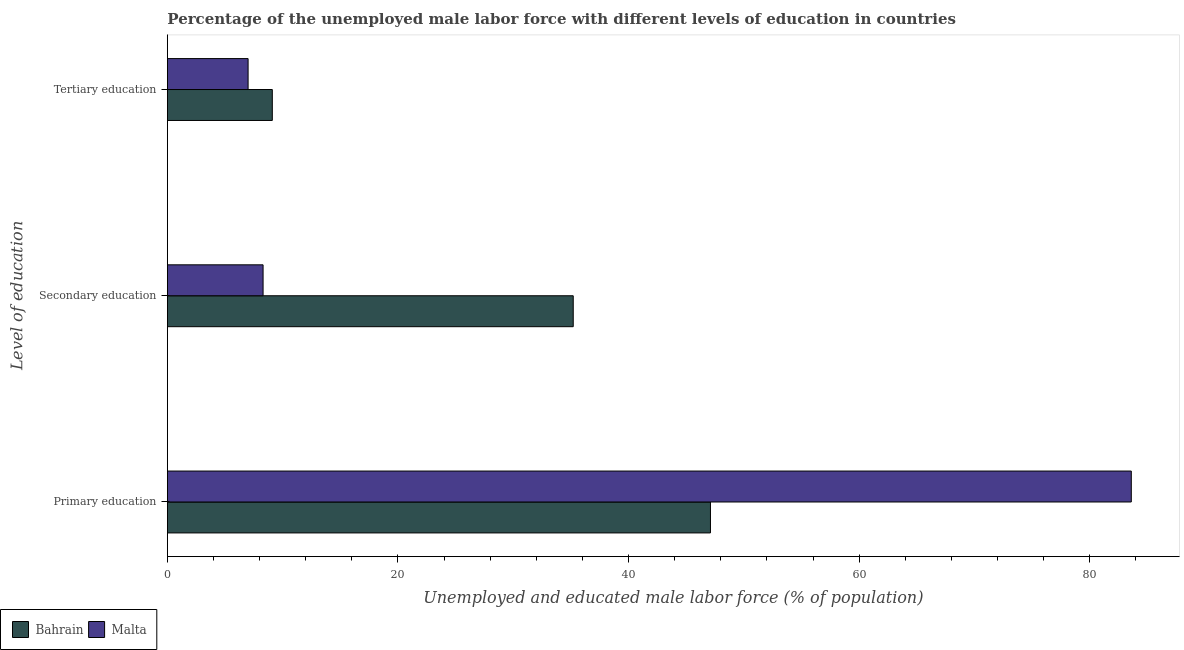How many groups of bars are there?
Give a very brief answer. 3. What is the label of the 2nd group of bars from the top?
Your answer should be very brief. Secondary education. What is the percentage of male labor force who received primary education in Bahrain?
Your answer should be very brief. 47.1. Across all countries, what is the maximum percentage of male labor force who received secondary education?
Provide a short and direct response. 35.2. In which country was the percentage of male labor force who received primary education maximum?
Your answer should be very brief. Malta. In which country was the percentage of male labor force who received secondary education minimum?
Offer a very short reply. Malta. What is the total percentage of male labor force who received tertiary education in the graph?
Provide a succinct answer. 16.1. What is the difference between the percentage of male labor force who received tertiary education in Malta and that in Bahrain?
Ensure brevity in your answer.  -2.1. What is the difference between the percentage of male labor force who received tertiary education in Bahrain and the percentage of male labor force who received secondary education in Malta?
Provide a succinct answer. 0.8. What is the average percentage of male labor force who received tertiary education per country?
Offer a very short reply. 8.05. What is the difference between the percentage of male labor force who received tertiary education and percentage of male labor force who received secondary education in Malta?
Keep it short and to the point. -1.3. What is the ratio of the percentage of male labor force who received secondary education in Malta to that in Bahrain?
Make the answer very short. 0.24. What is the difference between the highest and the second highest percentage of male labor force who received tertiary education?
Provide a short and direct response. 2.1. What is the difference between the highest and the lowest percentage of male labor force who received tertiary education?
Make the answer very short. 2.1. In how many countries, is the percentage of male labor force who received secondary education greater than the average percentage of male labor force who received secondary education taken over all countries?
Make the answer very short. 1. What does the 1st bar from the top in Secondary education represents?
Your response must be concise. Malta. What does the 1st bar from the bottom in Primary education represents?
Offer a very short reply. Bahrain. How many countries are there in the graph?
Your answer should be compact. 2. Are the values on the major ticks of X-axis written in scientific E-notation?
Provide a short and direct response. No. How many legend labels are there?
Offer a very short reply. 2. How are the legend labels stacked?
Your answer should be very brief. Horizontal. What is the title of the graph?
Keep it short and to the point. Percentage of the unemployed male labor force with different levels of education in countries. Does "Iran" appear as one of the legend labels in the graph?
Your answer should be compact. No. What is the label or title of the X-axis?
Provide a succinct answer. Unemployed and educated male labor force (% of population). What is the label or title of the Y-axis?
Provide a short and direct response. Level of education. What is the Unemployed and educated male labor force (% of population) in Bahrain in Primary education?
Offer a very short reply. 47.1. What is the Unemployed and educated male labor force (% of population) of Malta in Primary education?
Keep it short and to the point. 83.6. What is the Unemployed and educated male labor force (% of population) of Bahrain in Secondary education?
Your answer should be compact. 35.2. What is the Unemployed and educated male labor force (% of population) in Malta in Secondary education?
Give a very brief answer. 8.3. What is the Unemployed and educated male labor force (% of population) in Bahrain in Tertiary education?
Keep it short and to the point. 9.1. Across all Level of education, what is the maximum Unemployed and educated male labor force (% of population) in Bahrain?
Keep it short and to the point. 47.1. Across all Level of education, what is the maximum Unemployed and educated male labor force (% of population) of Malta?
Provide a succinct answer. 83.6. Across all Level of education, what is the minimum Unemployed and educated male labor force (% of population) in Bahrain?
Offer a terse response. 9.1. What is the total Unemployed and educated male labor force (% of population) in Bahrain in the graph?
Give a very brief answer. 91.4. What is the total Unemployed and educated male labor force (% of population) in Malta in the graph?
Keep it short and to the point. 98.9. What is the difference between the Unemployed and educated male labor force (% of population) in Bahrain in Primary education and that in Secondary education?
Offer a terse response. 11.9. What is the difference between the Unemployed and educated male labor force (% of population) of Malta in Primary education and that in Secondary education?
Provide a succinct answer. 75.3. What is the difference between the Unemployed and educated male labor force (% of population) in Malta in Primary education and that in Tertiary education?
Offer a terse response. 76.6. What is the difference between the Unemployed and educated male labor force (% of population) of Bahrain in Secondary education and that in Tertiary education?
Your answer should be very brief. 26.1. What is the difference between the Unemployed and educated male labor force (% of population) of Bahrain in Primary education and the Unemployed and educated male labor force (% of population) of Malta in Secondary education?
Your response must be concise. 38.8. What is the difference between the Unemployed and educated male labor force (% of population) in Bahrain in Primary education and the Unemployed and educated male labor force (% of population) in Malta in Tertiary education?
Offer a terse response. 40.1. What is the difference between the Unemployed and educated male labor force (% of population) of Bahrain in Secondary education and the Unemployed and educated male labor force (% of population) of Malta in Tertiary education?
Offer a terse response. 28.2. What is the average Unemployed and educated male labor force (% of population) in Bahrain per Level of education?
Keep it short and to the point. 30.47. What is the average Unemployed and educated male labor force (% of population) of Malta per Level of education?
Your answer should be very brief. 32.97. What is the difference between the Unemployed and educated male labor force (% of population) of Bahrain and Unemployed and educated male labor force (% of population) of Malta in Primary education?
Your answer should be very brief. -36.5. What is the difference between the Unemployed and educated male labor force (% of population) in Bahrain and Unemployed and educated male labor force (% of population) in Malta in Secondary education?
Offer a very short reply. 26.9. What is the difference between the Unemployed and educated male labor force (% of population) of Bahrain and Unemployed and educated male labor force (% of population) of Malta in Tertiary education?
Offer a very short reply. 2.1. What is the ratio of the Unemployed and educated male labor force (% of population) of Bahrain in Primary education to that in Secondary education?
Make the answer very short. 1.34. What is the ratio of the Unemployed and educated male labor force (% of population) in Malta in Primary education to that in Secondary education?
Provide a short and direct response. 10.07. What is the ratio of the Unemployed and educated male labor force (% of population) of Bahrain in Primary education to that in Tertiary education?
Give a very brief answer. 5.18. What is the ratio of the Unemployed and educated male labor force (% of population) of Malta in Primary education to that in Tertiary education?
Offer a terse response. 11.94. What is the ratio of the Unemployed and educated male labor force (% of population) of Bahrain in Secondary education to that in Tertiary education?
Keep it short and to the point. 3.87. What is the ratio of the Unemployed and educated male labor force (% of population) in Malta in Secondary education to that in Tertiary education?
Keep it short and to the point. 1.19. What is the difference between the highest and the second highest Unemployed and educated male labor force (% of population) of Bahrain?
Give a very brief answer. 11.9. What is the difference between the highest and the second highest Unemployed and educated male labor force (% of population) in Malta?
Provide a short and direct response. 75.3. What is the difference between the highest and the lowest Unemployed and educated male labor force (% of population) of Malta?
Your response must be concise. 76.6. 